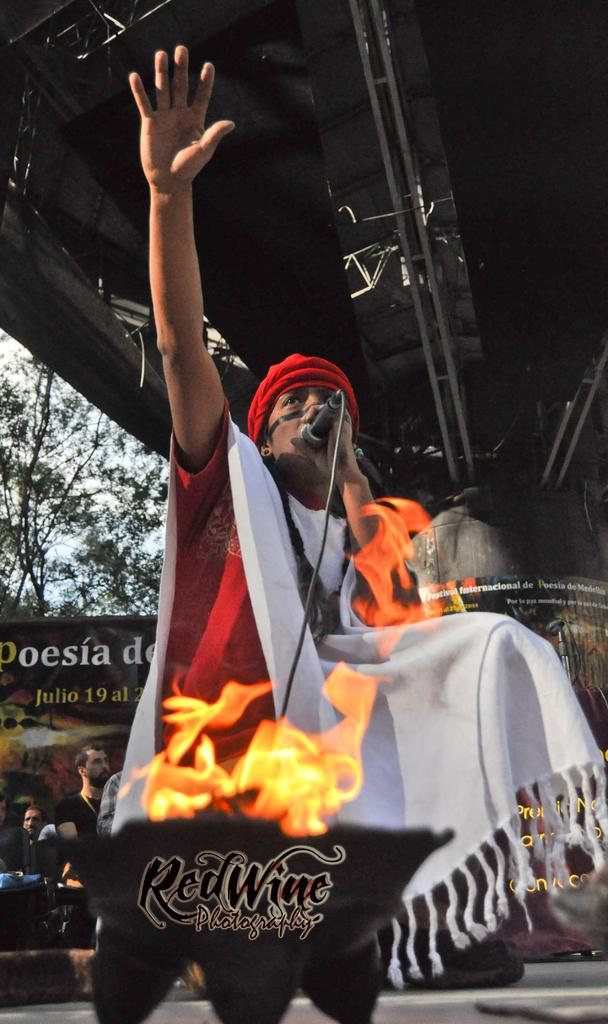Who is the main subject in the image? There is a man in the image. What is the man wearing? The man is wearing a red and white color dress. Where is the man located in the image? The man is standing on a stage. What is the man doing in the image? The man is singing into a microphone. What type of cart is being pulled by the bone in the image? There is no cart or bone present in the image; it features a man singing on a stage. 